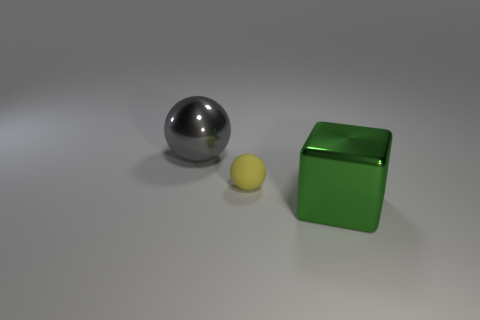Are there any other things that are the same size as the yellow matte ball?
Give a very brief answer. No. How many blocks are in front of the shiny object right of the big object to the left of the yellow object?
Offer a terse response. 0. What color is the cube that is the same size as the gray metallic thing?
Your answer should be compact. Green. The small matte object to the left of the metal object that is to the right of the big metallic thing on the left side of the big metallic cube is what shape?
Provide a short and direct response. Sphere. What number of gray spheres are on the left side of the tiny sphere that is behind the big metallic block?
Your answer should be compact. 1. There is a big metal thing in front of the gray shiny object; does it have the same shape as the metal thing to the left of the big green thing?
Make the answer very short. No. There is a small thing; how many large objects are in front of it?
Ensure brevity in your answer.  1. Is the material of the big object to the left of the yellow matte ball the same as the yellow sphere?
Keep it short and to the point. No. What color is the tiny rubber object that is the same shape as the large gray object?
Ensure brevity in your answer.  Yellow. What is the shape of the green metallic object?
Make the answer very short. Cube. 